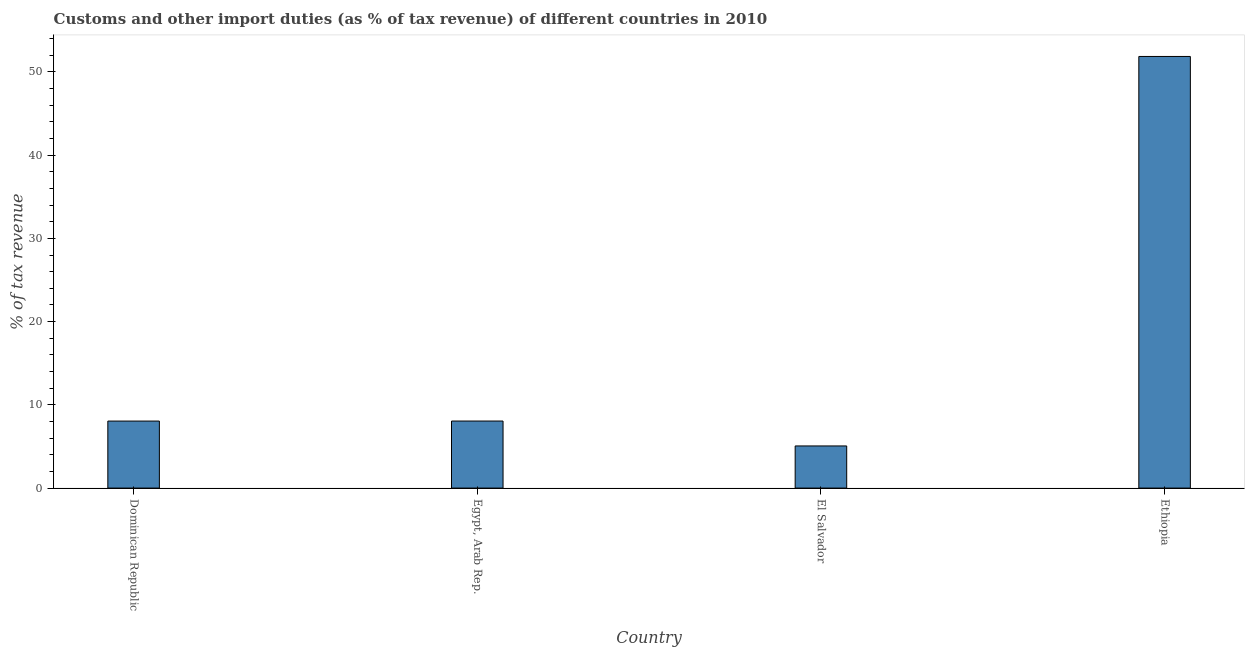Does the graph contain any zero values?
Your answer should be very brief. No. Does the graph contain grids?
Give a very brief answer. No. What is the title of the graph?
Make the answer very short. Customs and other import duties (as % of tax revenue) of different countries in 2010. What is the label or title of the X-axis?
Provide a succinct answer. Country. What is the label or title of the Y-axis?
Offer a very short reply. % of tax revenue. What is the customs and other import duties in El Salvador?
Offer a very short reply. 5.06. Across all countries, what is the maximum customs and other import duties?
Make the answer very short. 51.86. Across all countries, what is the minimum customs and other import duties?
Give a very brief answer. 5.06. In which country was the customs and other import duties maximum?
Keep it short and to the point. Ethiopia. In which country was the customs and other import duties minimum?
Keep it short and to the point. El Salvador. What is the sum of the customs and other import duties?
Keep it short and to the point. 73.02. What is the difference between the customs and other import duties in Dominican Republic and Ethiopia?
Your response must be concise. -43.8. What is the average customs and other import duties per country?
Give a very brief answer. 18.26. What is the median customs and other import duties?
Your answer should be compact. 8.05. What is the ratio of the customs and other import duties in Egypt, Arab Rep. to that in Ethiopia?
Your response must be concise. 0.15. Is the customs and other import duties in Dominican Republic less than that in El Salvador?
Ensure brevity in your answer.  No. What is the difference between the highest and the second highest customs and other import duties?
Offer a terse response. 43.8. Is the sum of the customs and other import duties in El Salvador and Ethiopia greater than the maximum customs and other import duties across all countries?
Make the answer very short. Yes. What is the difference between the highest and the lowest customs and other import duties?
Offer a terse response. 46.79. In how many countries, is the customs and other import duties greater than the average customs and other import duties taken over all countries?
Your answer should be very brief. 1. Are all the bars in the graph horizontal?
Your response must be concise. No. How many countries are there in the graph?
Offer a very short reply. 4. What is the difference between two consecutive major ticks on the Y-axis?
Offer a terse response. 10. Are the values on the major ticks of Y-axis written in scientific E-notation?
Your response must be concise. No. What is the % of tax revenue of Dominican Republic?
Make the answer very short. 8.05. What is the % of tax revenue of Egypt, Arab Rep.?
Your answer should be very brief. 8.05. What is the % of tax revenue of El Salvador?
Ensure brevity in your answer.  5.06. What is the % of tax revenue in Ethiopia?
Offer a terse response. 51.86. What is the difference between the % of tax revenue in Dominican Republic and Egypt, Arab Rep.?
Offer a terse response. -0. What is the difference between the % of tax revenue in Dominican Republic and El Salvador?
Offer a terse response. 2.99. What is the difference between the % of tax revenue in Dominican Republic and Ethiopia?
Your answer should be compact. -43.8. What is the difference between the % of tax revenue in Egypt, Arab Rep. and El Salvador?
Make the answer very short. 2.99. What is the difference between the % of tax revenue in Egypt, Arab Rep. and Ethiopia?
Your answer should be compact. -43.8. What is the difference between the % of tax revenue in El Salvador and Ethiopia?
Provide a short and direct response. -46.79. What is the ratio of the % of tax revenue in Dominican Republic to that in Egypt, Arab Rep.?
Offer a terse response. 1. What is the ratio of the % of tax revenue in Dominican Republic to that in El Salvador?
Offer a terse response. 1.59. What is the ratio of the % of tax revenue in Dominican Republic to that in Ethiopia?
Offer a terse response. 0.15. What is the ratio of the % of tax revenue in Egypt, Arab Rep. to that in El Salvador?
Offer a very short reply. 1.59. What is the ratio of the % of tax revenue in Egypt, Arab Rep. to that in Ethiopia?
Offer a terse response. 0.15. What is the ratio of the % of tax revenue in El Salvador to that in Ethiopia?
Ensure brevity in your answer.  0.1. 